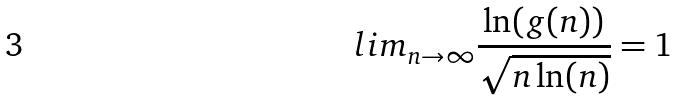<formula> <loc_0><loc_0><loc_500><loc_500>l i m _ { n \rightarrow \infty } \frac { \ln ( g ( n ) ) } { \sqrt { n \ln ( n ) } } = 1</formula> 